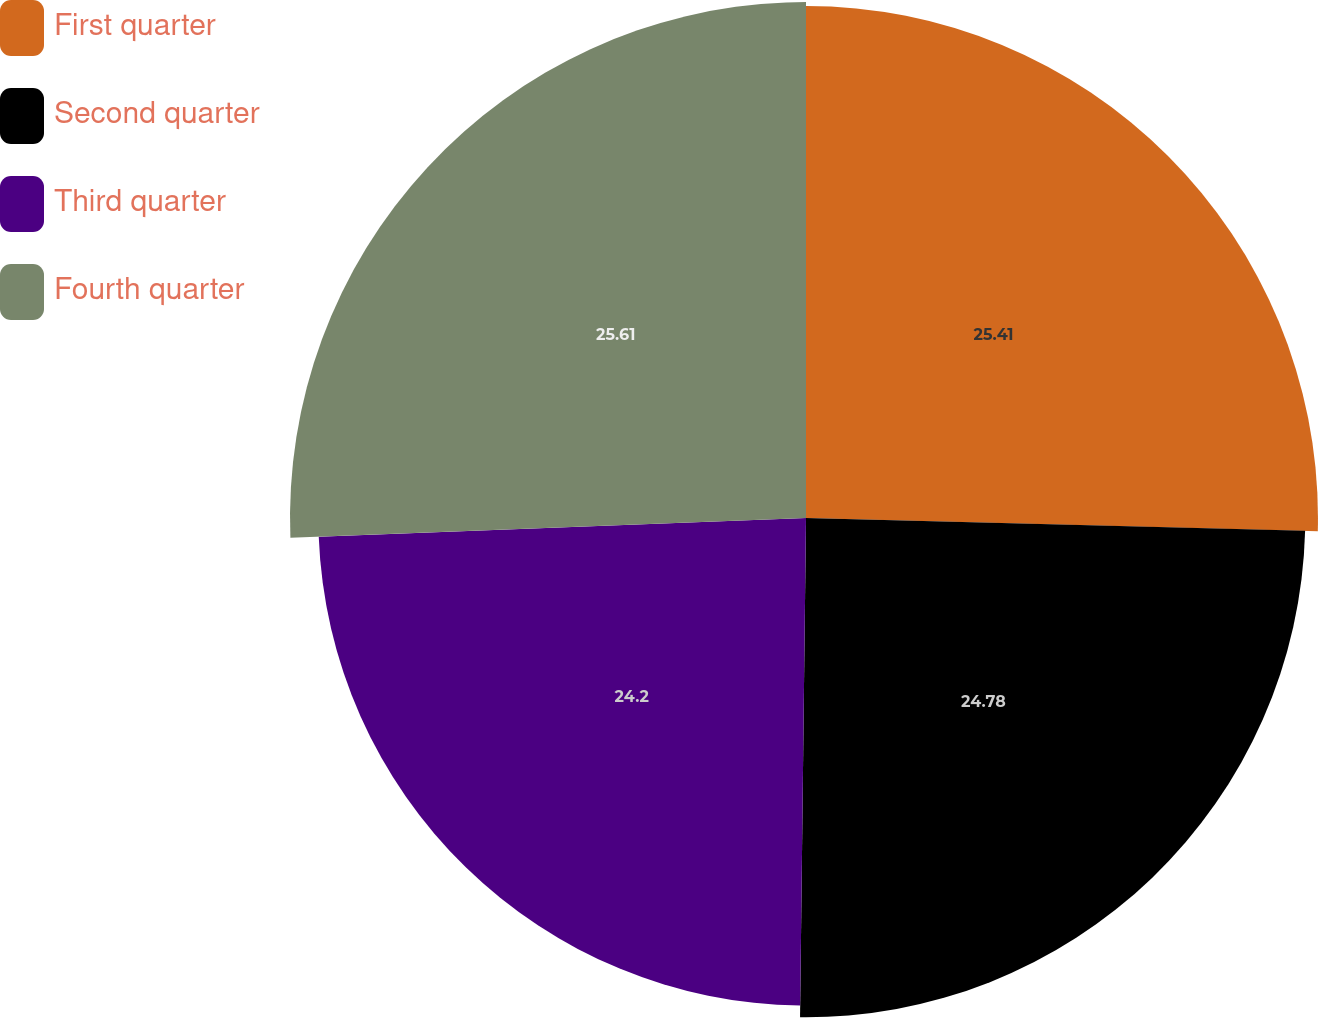<chart> <loc_0><loc_0><loc_500><loc_500><pie_chart><fcel>First quarter<fcel>Second quarter<fcel>Third quarter<fcel>Fourth quarter<nl><fcel>25.41%<fcel>24.78%<fcel>24.2%<fcel>25.61%<nl></chart> 